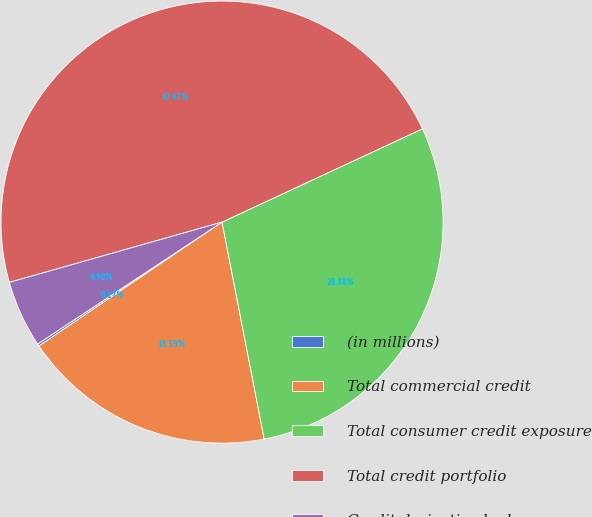Convert chart. <chart><loc_0><loc_0><loc_500><loc_500><pie_chart><fcel>(in millions)<fcel>Total commercial credit<fcel>Total consumer credit exposure<fcel>Total credit portfolio<fcel>Credit derivative hedges<nl><fcel>0.17%<fcel>18.59%<fcel>28.88%<fcel>47.47%<fcel>4.9%<nl></chart> 